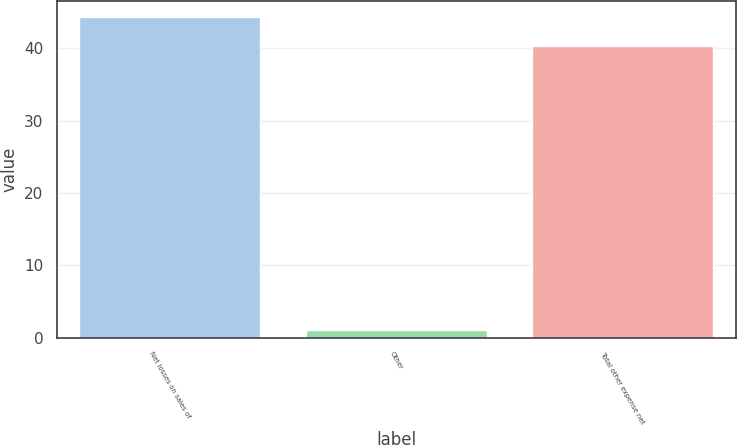Convert chart. <chart><loc_0><loc_0><loc_500><loc_500><bar_chart><fcel>Net losses on sales of<fcel>Other<fcel>Total other expense net<nl><fcel>44.33<fcel>1.1<fcel>40.3<nl></chart> 